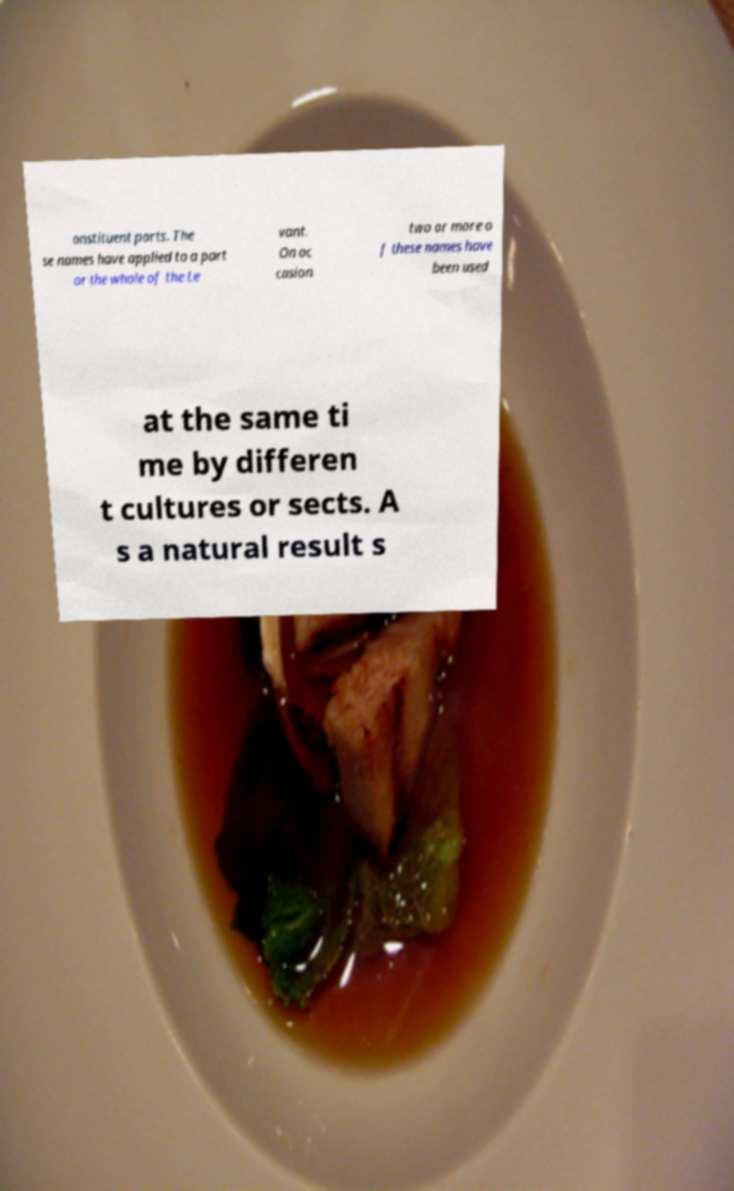What messages or text are displayed in this image? I need them in a readable, typed format. onstituent parts. The se names have applied to a part or the whole of the Le vant. On oc casion two or more o f these names have been used at the same ti me by differen t cultures or sects. A s a natural result s 